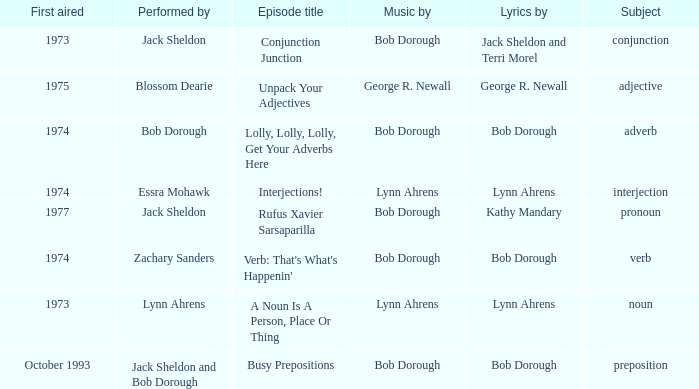When interjection is the subject how many performers are there? 1.0. 